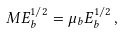Convert formula to latex. <formula><loc_0><loc_0><loc_500><loc_500>M E _ { b } ^ { 1 / 2 } = \mu _ { b } E _ { b } ^ { 1 / 2 } \, ,</formula> 